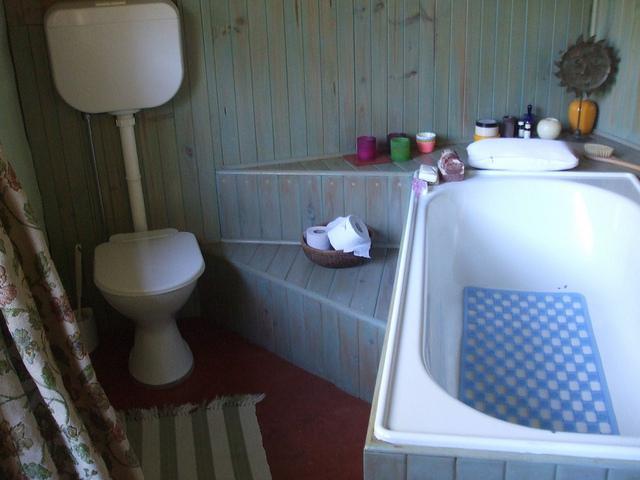What type of rolls are in the wicker basket?
Choose the right answer from the provided options to respond to the question.
Options: Jelly, toilet, camera, dinner. Toilet. 